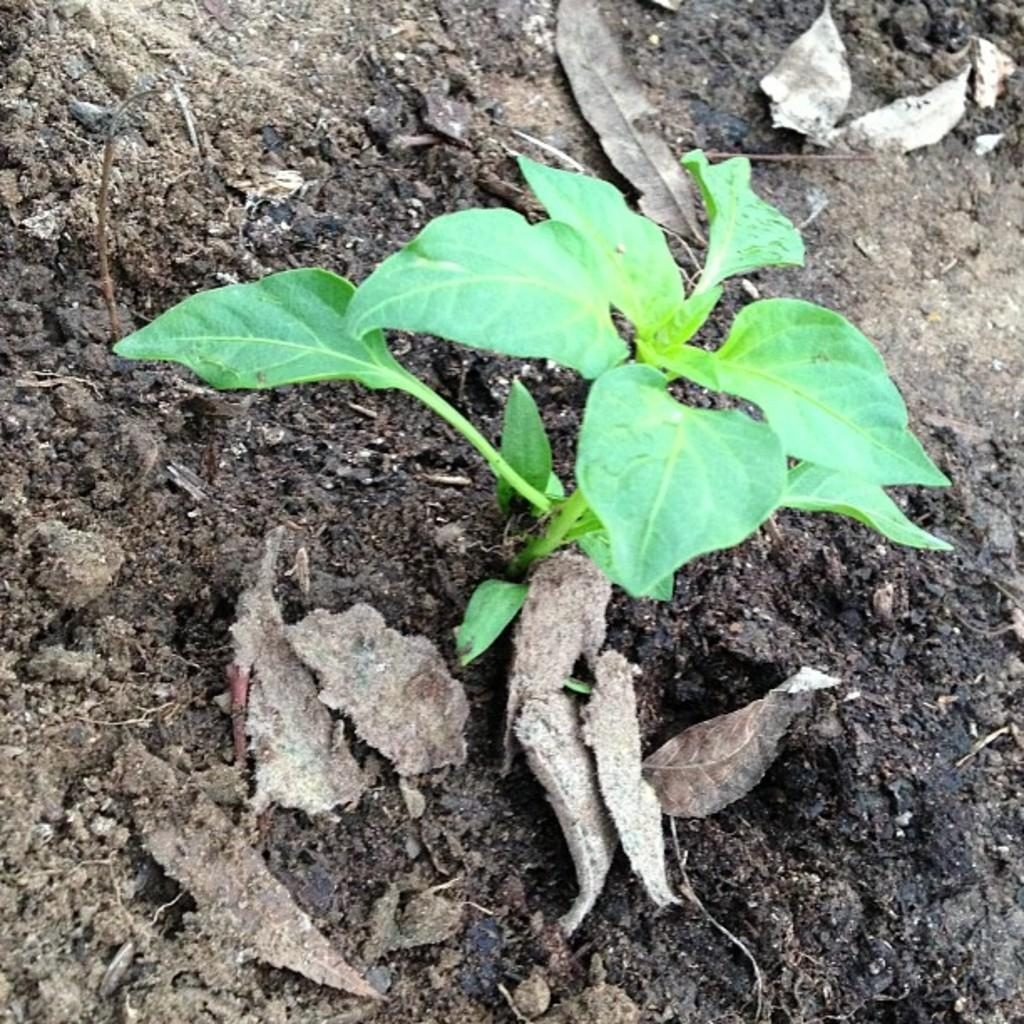What type of plant is visible in the image? There is a small plant in the image. What is the plant growing out of? The plant is budding out of black soil. Are there any additional features around the plant? Yes, there are dry leaves around the plant. What type of account is being discussed in the image? There is no account being discussed in the image; it features a small plant growing out of black soil with dry leaves around it. 